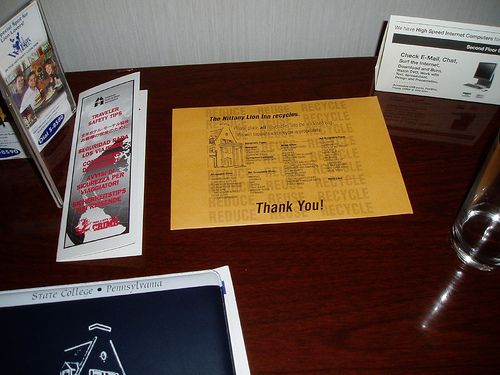<image>
Is the table under the glass? Yes. The table is positioned underneath the glass, with the glass above it in the vertical space. 